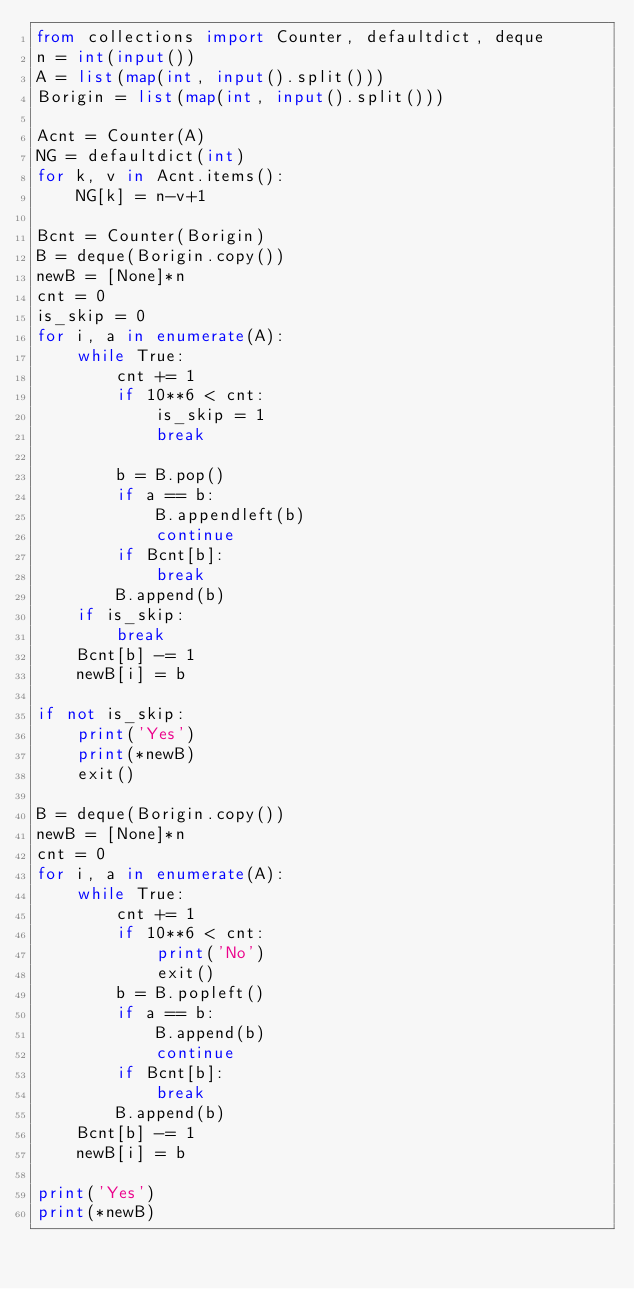<code> <loc_0><loc_0><loc_500><loc_500><_Python_>from collections import Counter, defaultdict, deque
n = int(input())
A = list(map(int, input().split()))
Borigin = list(map(int, input().split()))

Acnt = Counter(A)
NG = defaultdict(int)
for k, v in Acnt.items():
    NG[k] = n-v+1

Bcnt = Counter(Borigin)
B = deque(Borigin.copy())
newB = [None]*n
cnt = 0
is_skip = 0
for i, a in enumerate(A):
    while True:
        cnt += 1
        if 10**6 < cnt:
            is_skip = 1
            break

        b = B.pop()
        if a == b:
            B.appendleft(b)
            continue
        if Bcnt[b]:
            break
        B.append(b)
    if is_skip:
        break
    Bcnt[b] -= 1
    newB[i] = b

if not is_skip:
    print('Yes')
    print(*newB)
    exit()

B = deque(Borigin.copy())
newB = [None]*n
cnt = 0
for i, a in enumerate(A):
    while True:
        cnt += 1
        if 10**6 < cnt:
            print('No')
            exit()
        b = B.popleft()
        if a == b:
            B.append(b)
            continue
        if Bcnt[b]:
            break
        B.append(b)
    Bcnt[b] -= 1
    newB[i] = b

print('Yes')
print(*newB)
</code> 